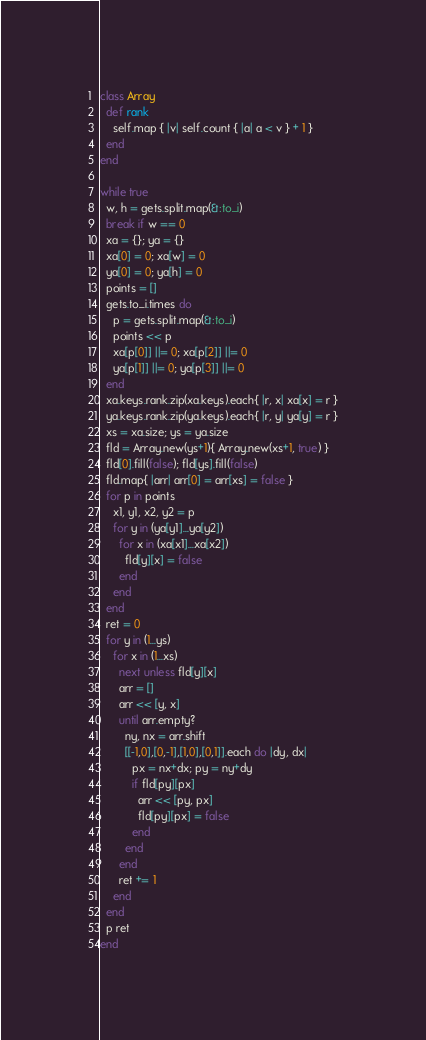<code> <loc_0><loc_0><loc_500><loc_500><_Ruby_>class Array
  def rank
    self.map { |v| self.count { |a| a < v } + 1 }
  end
end

while true
  w, h = gets.split.map(&:to_i)
  break if w == 0
  xa = {}; ya = {}
  xa[0] = 0; xa[w] = 0
  ya[0] = 0; ya[h] = 0
  points = []
  gets.to_i.times do
    p = gets.split.map(&:to_i)
    points << p
    xa[p[0]] ||= 0; xa[p[2]] ||= 0
    ya[p[1]] ||= 0; ya[p[3]] ||= 0
  end
  xa.keys.rank.zip(xa.keys).each{ |r, x| xa[x] = r }
  ya.keys.rank.zip(ya.keys).each{ |r, y| ya[y] = r }
  xs = xa.size; ys = ya.size
  fld = Array.new(ys+1){ Array.new(xs+1, true) }
  fld[0].fill(false); fld[ys].fill(false)
  fld.map{ |arr| arr[0] = arr[xs] = false }
  for p in points
    x1, y1, x2, y2 = p
    for y in (ya[y1]...ya[y2])
      for x in (xa[x1]...xa[x2])
        fld[y][x] = false
      end
    end
  end
  ret = 0
  for y in (1...ys)
    for x in (1...xs)
      next unless fld[y][x]
      arr = []
      arr << [y, x]
      until arr.empty?
        ny, nx = arr.shift
        [[-1,0],[0,-1],[1,0],[0,1]].each do |dy, dx|
          px = nx+dx; py = ny+dy
          if fld[py][px]
            arr << [py, px] 
            fld[py][px] = false
          end
        end
      end
      ret += 1
    end
  end
  p ret
end</code> 